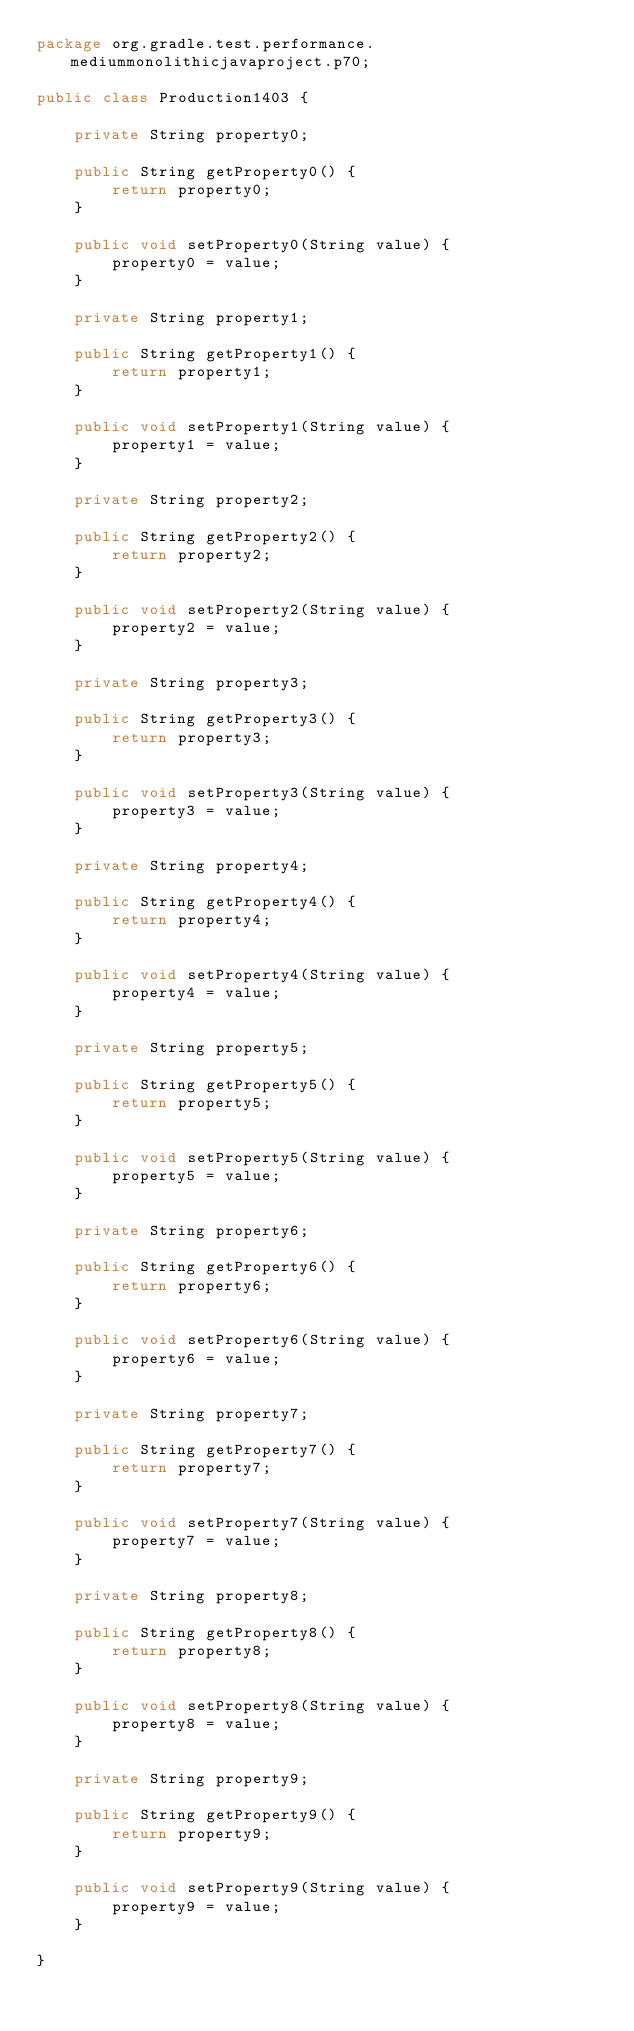Convert code to text. <code><loc_0><loc_0><loc_500><loc_500><_Java_>package org.gradle.test.performance.mediummonolithicjavaproject.p70;

public class Production1403 {        

    private String property0;

    public String getProperty0() {
        return property0;
    }

    public void setProperty0(String value) {
        property0 = value;
    }

    private String property1;

    public String getProperty1() {
        return property1;
    }

    public void setProperty1(String value) {
        property1 = value;
    }

    private String property2;

    public String getProperty2() {
        return property2;
    }

    public void setProperty2(String value) {
        property2 = value;
    }

    private String property3;

    public String getProperty3() {
        return property3;
    }

    public void setProperty3(String value) {
        property3 = value;
    }

    private String property4;

    public String getProperty4() {
        return property4;
    }

    public void setProperty4(String value) {
        property4 = value;
    }

    private String property5;

    public String getProperty5() {
        return property5;
    }

    public void setProperty5(String value) {
        property5 = value;
    }

    private String property6;

    public String getProperty6() {
        return property6;
    }

    public void setProperty6(String value) {
        property6 = value;
    }

    private String property7;

    public String getProperty7() {
        return property7;
    }

    public void setProperty7(String value) {
        property7 = value;
    }

    private String property8;

    public String getProperty8() {
        return property8;
    }

    public void setProperty8(String value) {
        property8 = value;
    }

    private String property9;

    public String getProperty9() {
        return property9;
    }

    public void setProperty9(String value) {
        property9 = value;
    }

}</code> 